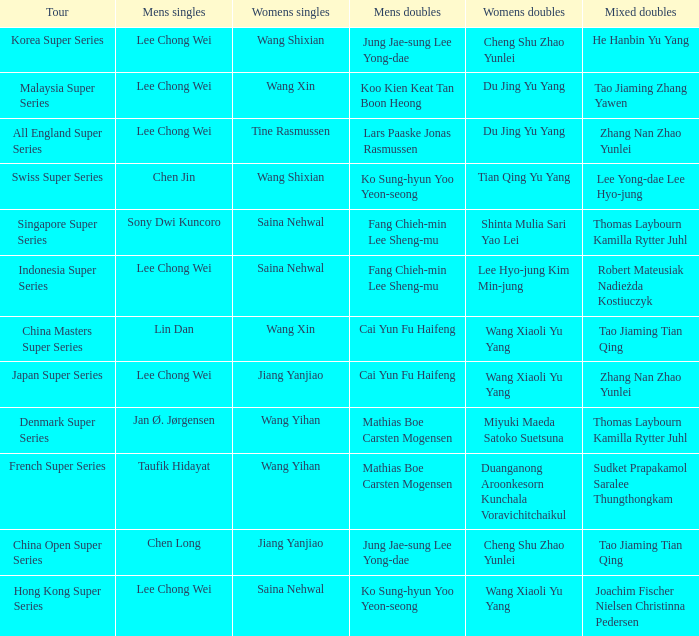Who is the womens doubles on the tour french super series? Duanganong Aroonkesorn Kunchala Voravichitchaikul. 